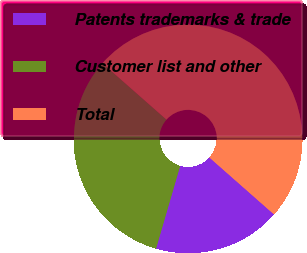Convert chart. <chart><loc_0><loc_0><loc_500><loc_500><pie_chart><fcel>Patents trademarks & trade<fcel>Customer list and other<fcel>Total<nl><fcel>18.02%<fcel>31.98%<fcel>50.0%<nl></chart> 